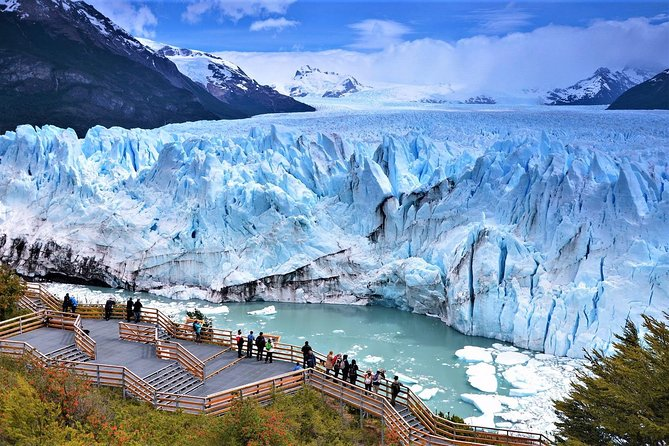Can you tell me more about why this glacier is so blue? The vibrant blue color of the Perito Moreno Glacier, and glaciers in general, is due to the absorption and scattering of light. The dense ice of the glacier absorbs most of the color spectrum, except for blue, which is scattered and thus visible to the eye. This specific shade of blue is particularly intense in the Perito Moreno Glacier due to its high purity and the immense pressures it has undergone, which increase the ice density and enhance the blue appearance. 